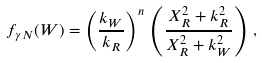<formula> <loc_0><loc_0><loc_500><loc_500>f _ { \gamma N } ( W ) = \left ( \frac { k _ { W } } { k _ { R } } \right ) ^ { n } \, \left ( \frac { X ^ { 2 } _ { R } + k _ { R } ^ { 2 } } { X ^ { 2 } _ { R } + k _ { W } ^ { 2 } } \right ) \, ,</formula> 